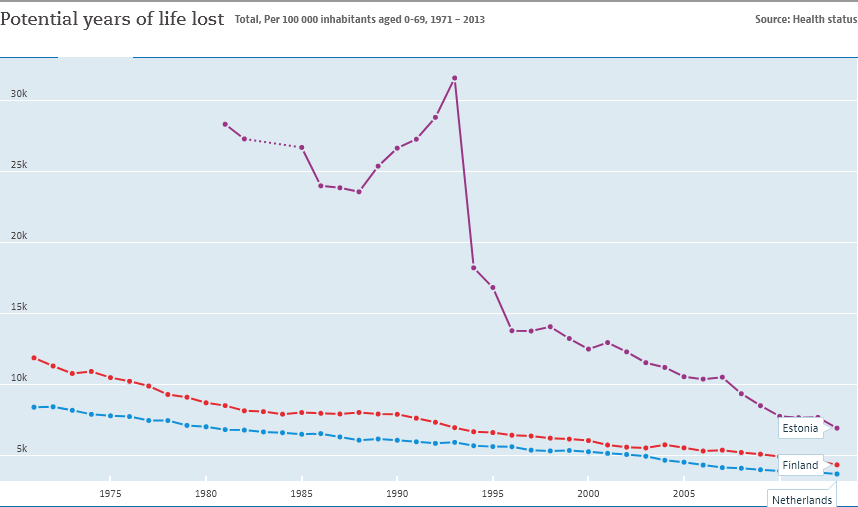List a handful of essential elements in this visual. The color bar that is located between the blue and purple bar in the graph is red. Finland displayed more than 10,000 units in 1975. 